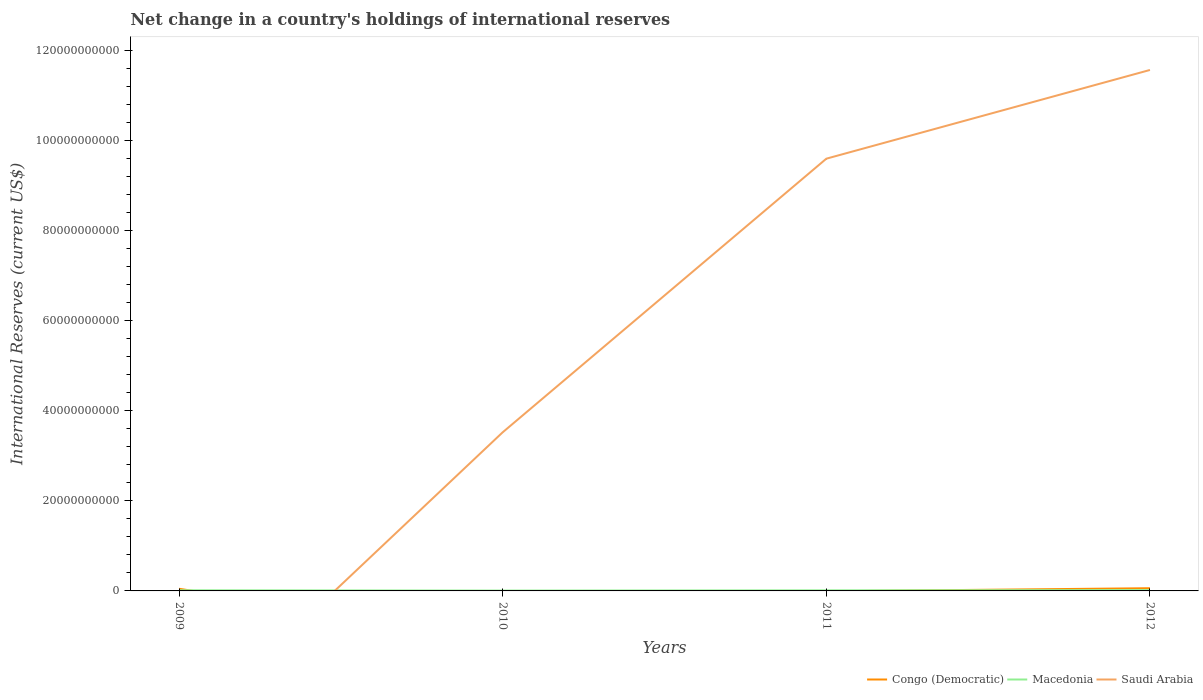How many different coloured lines are there?
Provide a short and direct response. 3. Does the line corresponding to Macedonia intersect with the line corresponding to Congo (Democratic)?
Provide a short and direct response. Yes. Across all years, what is the maximum international reserves in Macedonia?
Keep it short and to the point. 7.81e+07. What is the total international reserves in Macedonia in the graph?
Provide a succinct answer. -3.77e+07. What is the difference between the highest and the second highest international reserves in Macedonia?
Provide a succinct answer. 1.07e+08. Is the international reserves in Saudi Arabia strictly greater than the international reserves in Macedonia over the years?
Your answer should be very brief. No. How many years are there in the graph?
Make the answer very short. 4. What is the difference between two consecutive major ticks on the Y-axis?
Keep it short and to the point. 2.00e+1. Are the values on the major ticks of Y-axis written in scientific E-notation?
Provide a short and direct response. No. Does the graph contain grids?
Your response must be concise. No. How many legend labels are there?
Make the answer very short. 3. What is the title of the graph?
Provide a short and direct response. Net change in a country's holdings of international reserves. What is the label or title of the X-axis?
Your answer should be very brief. Years. What is the label or title of the Y-axis?
Keep it short and to the point. International Reserves (current US$). What is the International Reserves (current US$) of Congo (Democratic) in 2009?
Your answer should be very brief. 4.80e+08. What is the International Reserves (current US$) of Macedonia in 2009?
Offer a terse response. 1.47e+08. What is the International Reserves (current US$) of Macedonia in 2010?
Make the answer very short. 7.81e+07. What is the International Reserves (current US$) of Saudi Arabia in 2010?
Your answer should be compact. 3.53e+1. What is the International Reserves (current US$) of Macedonia in 2011?
Give a very brief answer. 1.33e+08. What is the International Reserves (current US$) of Saudi Arabia in 2011?
Provide a succinct answer. 9.61e+1. What is the International Reserves (current US$) in Congo (Democratic) in 2012?
Offer a very short reply. 6.01e+08. What is the International Reserves (current US$) of Macedonia in 2012?
Your answer should be compact. 1.85e+08. What is the International Reserves (current US$) in Saudi Arabia in 2012?
Provide a short and direct response. 1.16e+11. Across all years, what is the maximum International Reserves (current US$) in Congo (Democratic)?
Your response must be concise. 6.01e+08. Across all years, what is the maximum International Reserves (current US$) of Macedonia?
Your answer should be very brief. 1.85e+08. Across all years, what is the maximum International Reserves (current US$) of Saudi Arabia?
Ensure brevity in your answer.  1.16e+11. Across all years, what is the minimum International Reserves (current US$) in Congo (Democratic)?
Offer a very short reply. 0. Across all years, what is the minimum International Reserves (current US$) in Macedonia?
Keep it short and to the point. 7.81e+07. What is the total International Reserves (current US$) in Congo (Democratic) in the graph?
Offer a terse response. 1.08e+09. What is the total International Reserves (current US$) of Macedonia in the graph?
Give a very brief answer. 5.43e+08. What is the total International Reserves (current US$) of Saudi Arabia in the graph?
Your response must be concise. 2.47e+11. What is the difference between the International Reserves (current US$) in Macedonia in 2009 and that in 2010?
Ensure brevity in your answer.  6.88e+07. What is the difference between the International Reserves (current US$) of Macedonia in 2009 and that in 2011?
Your answer should be very brief. 1.42e+07. What is the difference between the International Reserves (current US$) in Congo (Democratic) in 2009 and that in 2012?
Make the answer very short. -1.21e+08. What is the difference between the International Reserves (current US$) of Macedonia in 2009 and that in 2012?
Keep it short and to the point. -3.77e+07. What is the difference between the International Reserves (current US$) of Macedonia in 2010 and that in 2011?
Offer a terse response. -5.47e+07. What is the difference between the International Reserves (current US$) in Saudi Arabia in 2010 and that in 2011?
Provide a short and direct response. -6.08e+1. What is the difference between the International Reserves (current US$) in Macedonia in 2010 and that in 2012?
Your answer should be very brief. -1.07e+08. What is the difference between the International Reserves (current US$) in Saudi Arabia in 2010 and that in 2012?
Your answer should be very brief. -8.05e+1. What is the difference between the International Reserves (current US$) of Macedonia in 2011 and that in 2012?
Provide a succinct answer. -5.19e+07. What is the difference between the International Reserves (current US$) of Saudi Arabia in 2011 and that in 2012?
Your answer should be very brief. -1.97e+1. What is the difference between the International Reserves (current US$) in Congo (Democratic) in 2009 and the International Reserves (current US$) in Macedonia in 2010?
Ensure brevity in your answer.  4.01e+08. What is the difference between the International Reserves (current US$) of Congo (Democratic) in 2009 and the International Reserves (current US$) of Saudi Arabia in 2010?
Ensure brevity in your answer.  -3.48e+1. What is the difference between the International Reserves (current US$) of Macedonia in 2009 and the International Reserves (current US$) of Saudi Arabia in 2010?
Your response must be concise. -3.51e+1. What is the difference between the International Reserves (current US$) in Congo (Democratic) in 2009 and the International Reserves (current US$) in Macedonia in 2011?
Offer a very short reply. 3.47e+08. What is the difference between the International Reserves (current US$) of Congo (Democratic) in 2009 and the International Reserves (current US$) of Saudi Arabia in 2011?
Your answer should be compact. -9.56e+1. What is the difference between the International Reserves (current US$) in Macedonia in 2009 and the International Reserves (current US$) in Saudi Arabia in 2011?
Give a very brief answer. -9.59e+1. What is the difference between the International Reserves (current US$) in Congo (Democratic) in 2009 and the International Reserves (current US$) in Macedonia in 2012?
Offer a terse response. 2.95e+08. What is the difference between the International Reserves (current US$) of Congo (Democratic) in 2009 and the International Reserves (current US$) of Saudi Arabia in 2012?
Your response must be concise. -1.15e+11. What is the difference between the International Reserves (current US$) in Macedonia in 2009 and the International Reserves (current US$) in Saudi Arabia in 2012?
Make the answer very short. -1.16e+11. What is the difference between the International Reserves (current US$) of Macedonia in 2010 and the International Reserves (current US$) of Saudi Arabia in 2011?
Your answer should be compact. -9.60e+1. What is the difference between the International Reserves (current US$) in Macedonia in 2010 and the International Reserves (current US$) in Saudi Arabia in 2012?
Make the answer very short. -1.16e+11. What is the difference between the International Reserves (current US$) in Macedonia in 2011 and the International Reserves (current US$) in Saudi Arabia in 2012?
Keep it short and to the point. -1.16e+11. What is the average International Reserves (current US$) in Congo (Democratic) per year?
Ensure brevity in your answer.  2.70e+08. What is the average International Reserves (current US$) of Macedonia per year?
Your response must be concise. 1.36e+08. What is the average International Reserves (current US$) of Saudi Arabia per year?
Your response must be concise. 6.18e+1. In the year 2009, what is the difference between the International Reserves (current US$) of Congo (Democratic) and International Reserves (current US$) of Macedonia?
Your response must be concise. 3.33e+08. In the year 2010, what is the difference between the International Reserves (current US$) of Macedonia and International Reserves (current US$) of Saudi Arabia?
Your answer should be compact. -3.52e+1. In the year 2011, what is the difference between the International Reserves (current US$) in Macedonia and International Reserves (current US$) in Saudi Arabia?
Provide a succinct answer. -9.59e+1. In the year 2012, what is the difference between the International Reserves (current US$) of Congo (Democratic) and International Reserves (current US$) of Macedonia?
Provide a short and direct response. 4.16e+08. In the year 2012, what is the difference between the International Reserves (current US$) in Congo (Democratic) and International Reserves (current US$) in Saudi Arabia?
Offer a terse response. -1.15e+11. In the year 2012, what is the difference between the International Reserves (current US$) in Macedonia and International Reserves (current US$) in Saudi Arabia?
Offer a terse response. -1.16e+11. What is the ratio of the International Reserves (current US$) of Macedonia in 2009 to that in 2010?
Your answer should be compact. 1.88. What is the ratio of the International Reserves (current US$) in Macedonia in 2009 to that in 2011?
Ensure brevity in your answer.  1.11. What is the ratio of the International Reserves (current US$) in Congo (Democratic) in 2009 to that in 2012?
Provide a succinct answer. 0.8. What is the ratio of the International Reserves (current US$) of Macedonia in 2009 to that in 2012?
Make the answer very short. 0.8. What is the ratio of the International Reserves (current US$) in Macedonia in 2010 to that in 2011?
Your response must be concise. 0.59. What is the ratio of the International Reserves (current US$) in Saudi Arabia in 2010 to that in 2011?
Offer a very short reply. 0.37. What is the ratio of the International Reserves (current US$) in Macedonia in 2010 to that in 2012?
Give a very brief answer. 0.42. What is the ratio of the International Reserves (current US$) in Saudi Arabia in 2010 to that in 2012?
Your answer should be compact. 0.3. What is the ratio of the International Reserves (current US$) in Macedonia in 2011 to that in 2012?
Your answer should be compact. 0.72. What is the ratio of the International Reserves (current US$) in Saudi Arabia in 2011 to that in 2012?
Give a very brief answer. 0.83. What is the difference between the highest and the second highest International Reserves (current US$) of Macedonia?
Offer a terse response. 3.77e+07. What is the difference between the highest and the second highest International Reserves (current US$) of Saudi Arabia?
Give a very brief answer. 1.97e+1. What is the difference between the highest and the lowest International Reserves (current US$) of Congo (Democratic)?
Offer a very short reply. 6.01e+08. What is the difference between the highest and the lowest International Reserves (current US$) of Macedonia?
Make the answer very short. 1.07e+08. What is the difference between the highest and the lowest International Reserves (current US$) of Saudi Arabia?
Keep it short and to the point. 1.16e+11. 